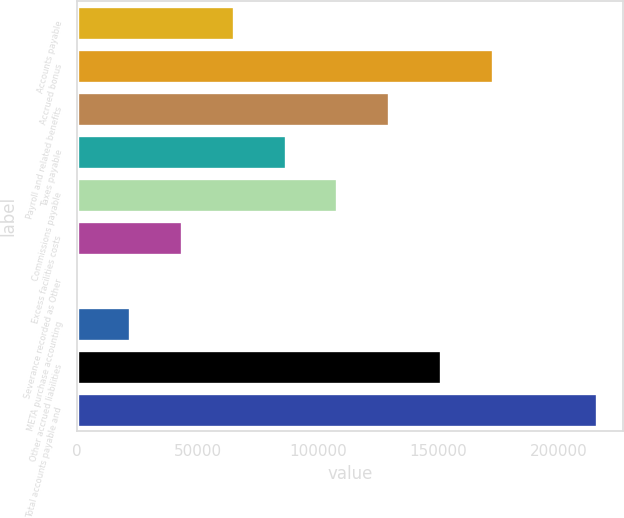<chart> <loc_0><loc_0><loc_500><loc_500><bar_chart><fcel>Accounts payable<fcel>Accrued bonus<fcel>Payroll and related benefits<fcel>Taxes payable<fcel>Commissions payable<fcel>Excess facilities costs<fcel>Severance recorded as Other<fcel>META purchase accounting<fcel>Other accrued liabilities<fcel>Total accounts payable and<nl><fcel>65032.2<fcel>172859<fcel>129728<fcel>86597.6<fcel>108163<fcel>43466.8<fcel>336<fcel>21901.4<fcel>151294<fcel>215990<nl></chart> 